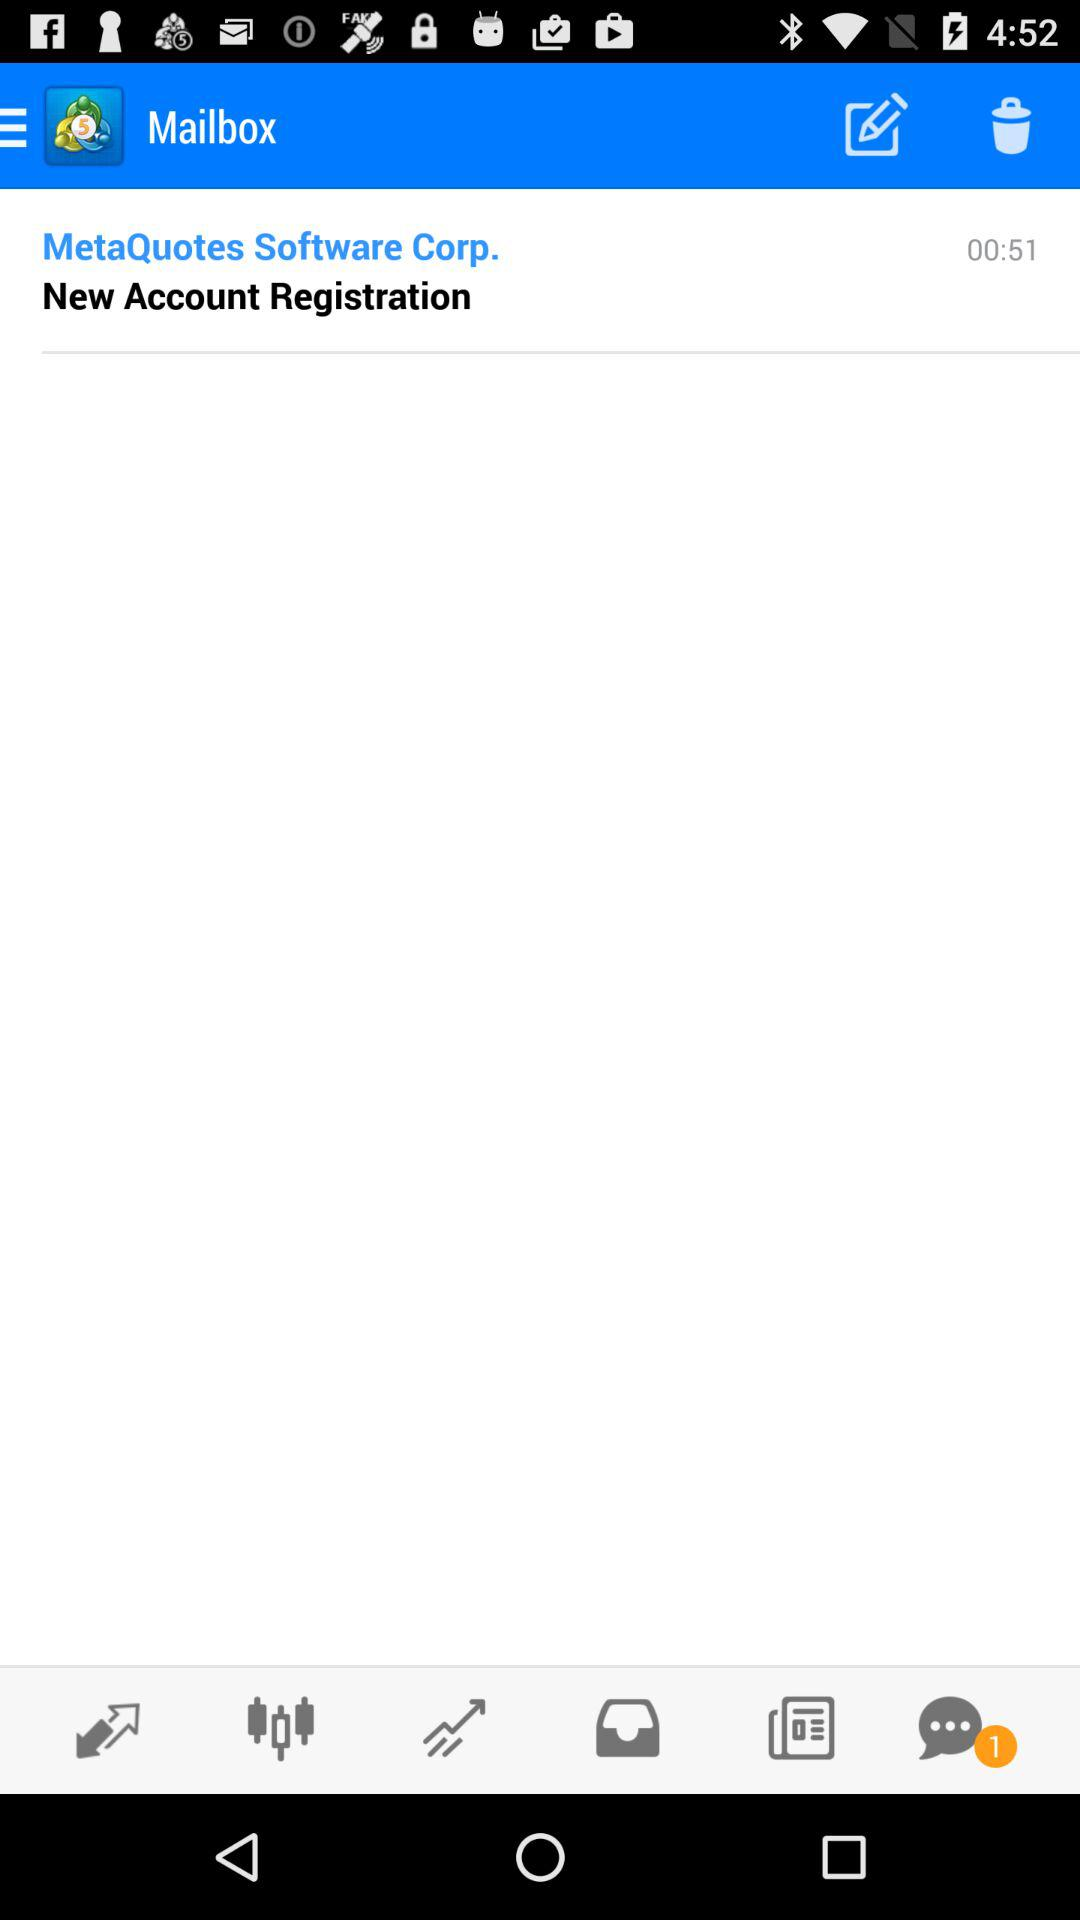How many unread chats are there? There is 1 unread chat. 